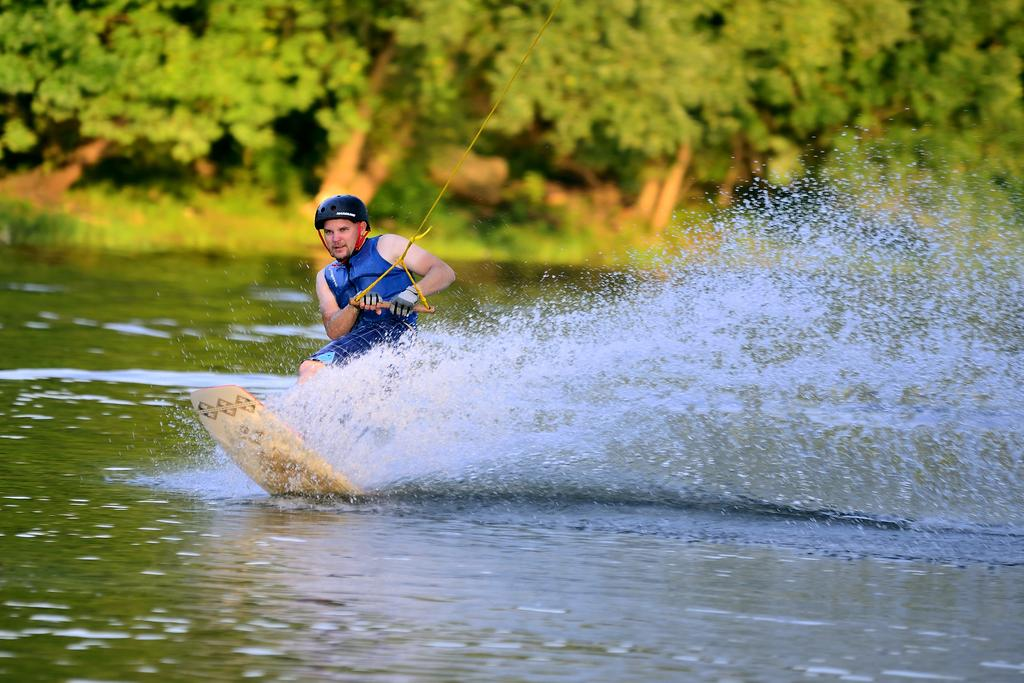Who is present in the image? There is a man in the image. What is the man wearing on his head? The man is wearing a helmet. What activity is the man engaged in? The man is surfing in the water. What can be seen at the bottom of the image? There is water visible at the bottom of the image. What type of natural scenery is visible in the background? There are trees in the background of the image. What is the man's belief about the existence of rabbits in the water while he is surfing? There is no information about the man's beliefs or rabbits in the image, as it only shows a man surfing in the water with trees in the background. 